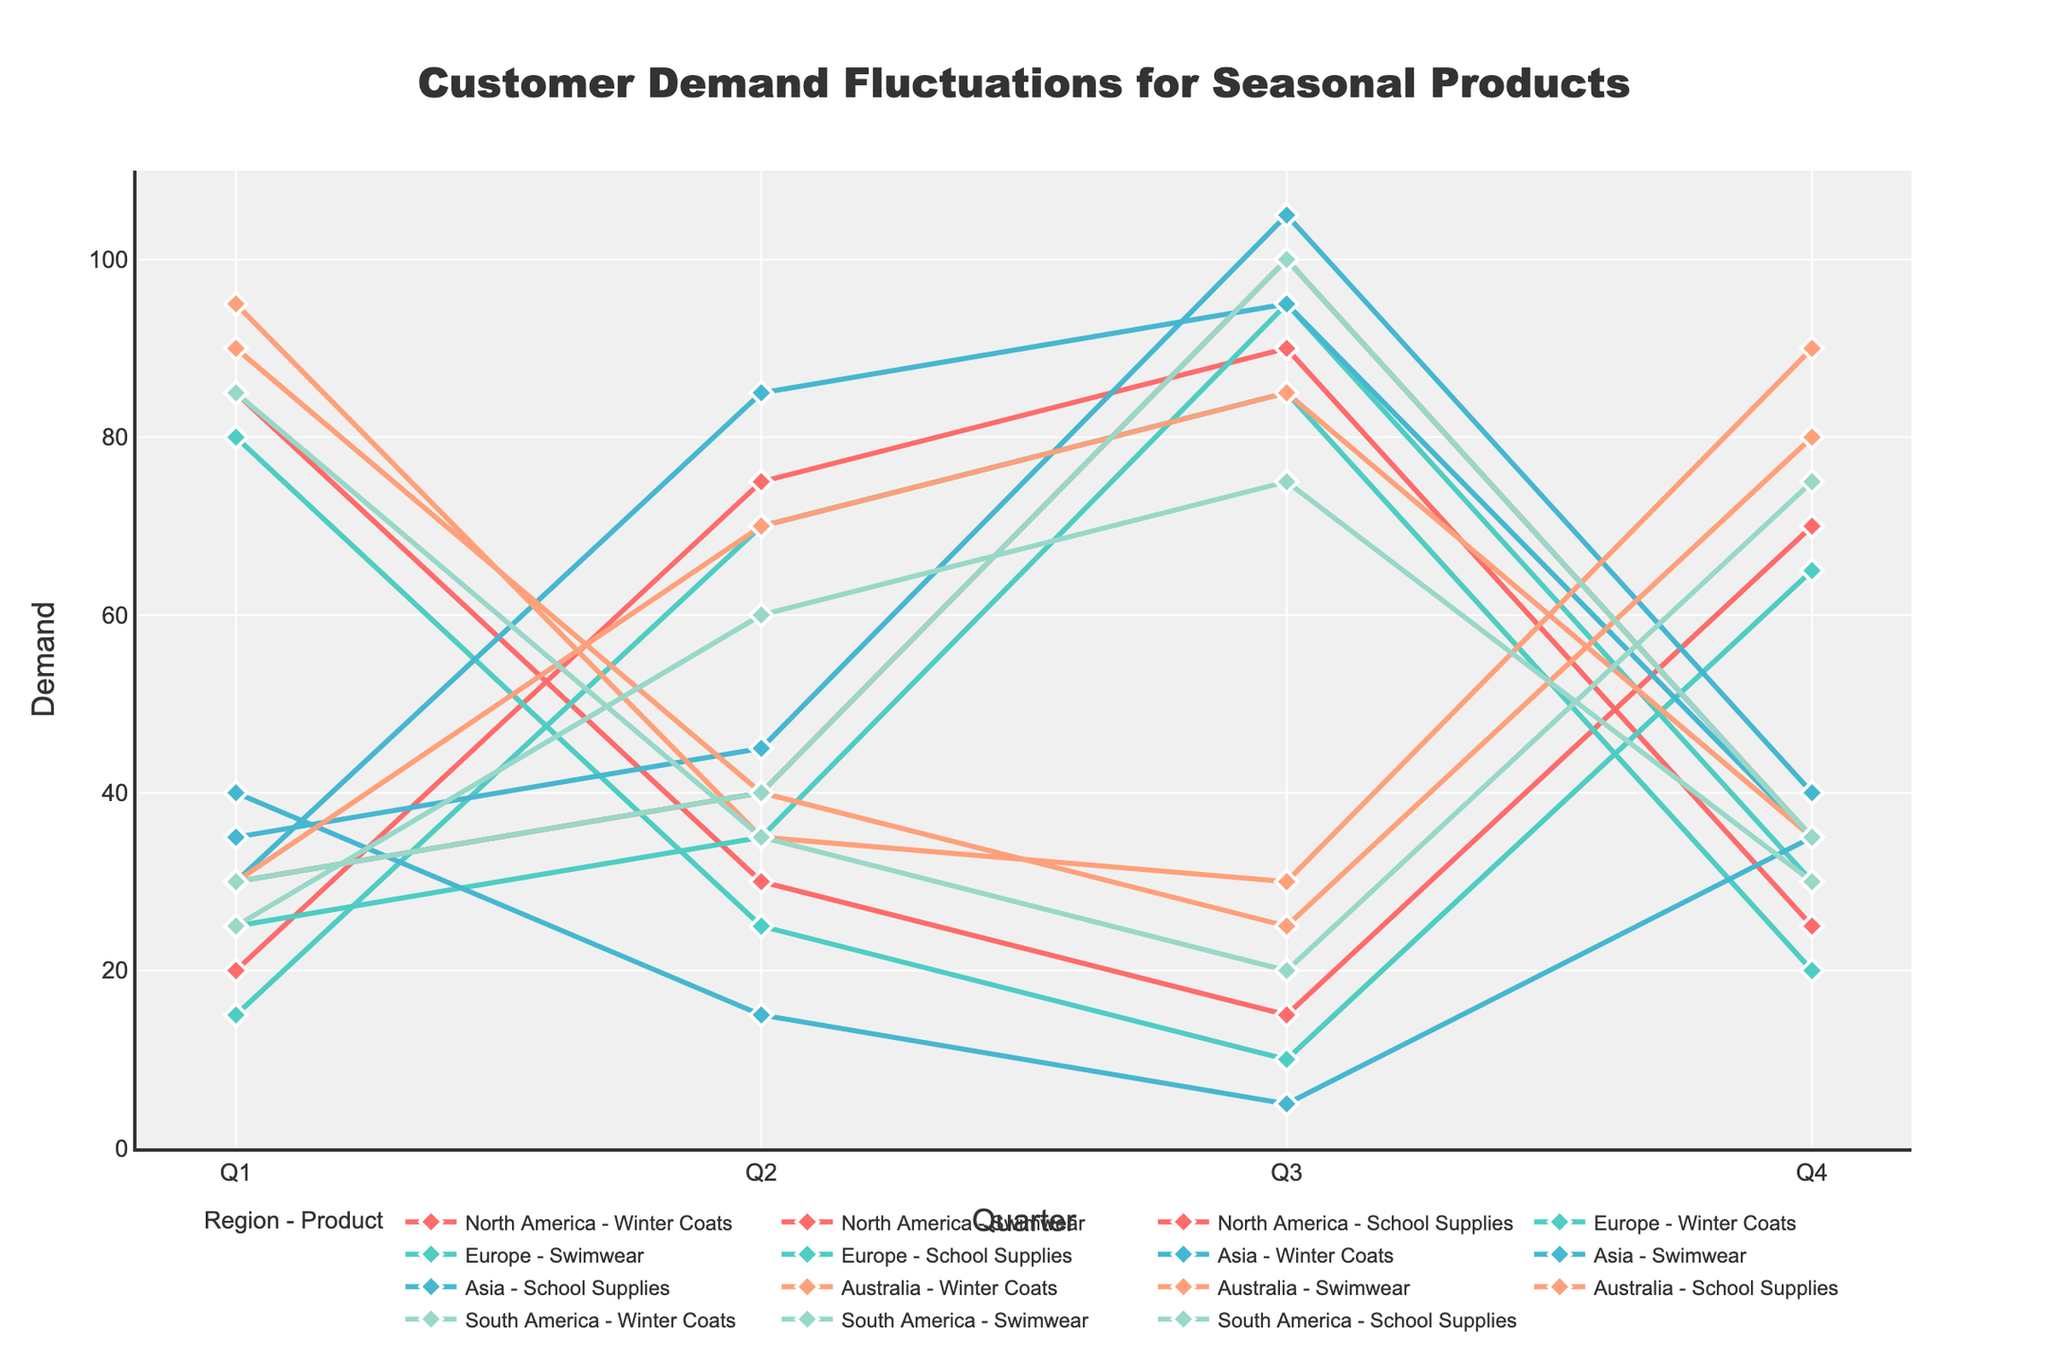Which region shows the highest demand for Winter Coats in Q2? First, look for all the Winter Coats data points in Q2 for each region. North America has 30, Europe has 25, Asia has 15, Australia has 70, and South America has 60. Australia has the highest value.
Answer: Australia Which product had the highest demand in Q3 for Asia? Look at the demand values for Asia in Q3 for all products: Winter Coats (5), Swimwear (95), School Supplies (105). School Supplies have the highest demand.
Answer: School Supplies How does the demand for Swimwear in Q1 compare across all regions? Compare the Q1 values for Swimwear across all regions: North America (20), Europe (15), Asia (30), Australia (90), South America (85). Australia has the highest demand followed by South America.
Answer: Australia > South America > Asia > North America > Europe What is the average demand for School Supplies in Q4 across all regions? Sum the Q4 values for School Supplies: North America (35), Europe (30), Asia (40), Australia (90), South America (35), resulting in 35 + 30 + 40 + 90 + 35 = 230. There are 5 regions, so divide 230 by 5.
Answer: 46 Which region shows the most fluctuation in demand for a single product across quarters? Look at the range (max - min) for each product in each region. For example, for Winter Coats in North America: max is 85, and min is 15 with a range of 70. For Australia, the ranges are Winter Coats: 85-30=55, Swimwear: 90-25=65, and School Supplies: 95-30=65. North America Winter Coats show the highest fluctuation with a range of 70.
Answer: North America - Winter Coats Which quarter generally has the highest demand for Swimwear across all regions except Australia? Look at the Swimwear demand values for North America, Europe, Asia, and South America excluding Australia: Q1 (20+15+30+85), Q2 (75+70+85+35), Q3 (90+85+95+20), Q4 (25+20+35+75). Calculate the sums: Q1(150), Q2(265), Q3(290), Q4(155). Q3 has the highest sum of 290.
Answer: Q3 What is the combined Q2 demand for Winter Coats in Europe and South America? Add the Q2 values for Winter Coats in Europe (25) and South America (60).
Answer: 85 Which product in North America has the lowest demand in Q4? Look at the demand values in Q4 for all products in North America: Winter Coats (70), Swimwear (25), School Supplies (35). Swimwear has the lowest demand.
Answer: Swimwear Which region shows the highest total demand for all products in Q1? Sum the Q1 values for each region: 
North America (85 + 20 + 30 = 135), 
Europe (80 + 15 + 25 = 120), 
Asia (40 + 30 + 35 = 105), 
Australia (30 + 90 + 95 = 215), 
South America (25 + 85 + 30 = 140). 
Australia has the highest total demand.
Answer: Australia 